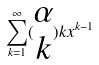<formula> <loc_0><loc_0><loc_500><loc_500>\sum _ { k = 1 } ^ { \infty } ( \begin{matrix} \alpha \\ k \end{matrix} ) k x ^ { k - 1 }</formula> 